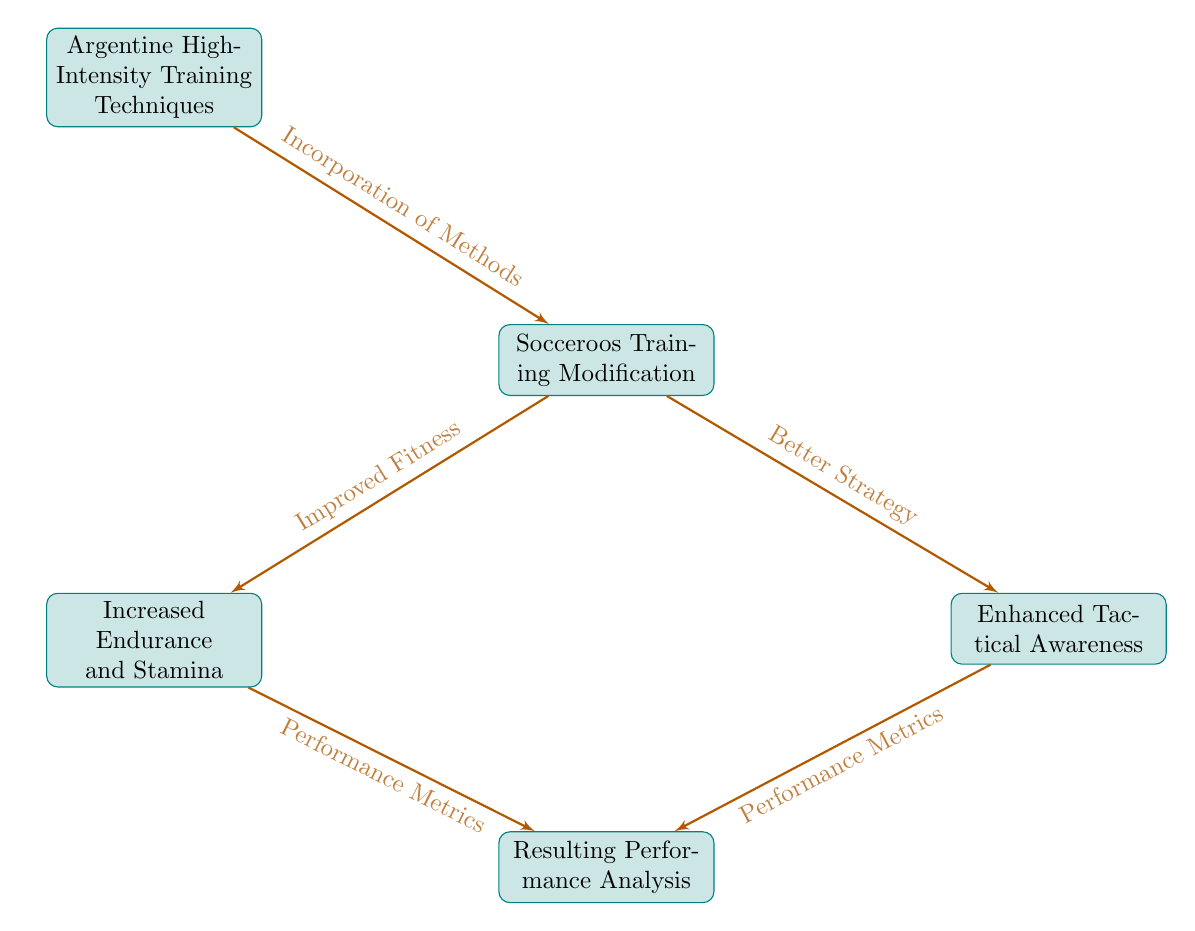What is the title of the first node? The first node is labeled "Argentine High-Intensity Training Techniques," which is the starting point of the flow chart.
Answer: Argentine High-Intensity Training Techniques How many nodes are in the diagram? The diagram consists of five distinct nodes that outline the various influences and modifications related to training.
Answer: 5 What is the relationship between "Socceroos Training Modification" and "Increased Endurance and Stamina"? "Socceroos Training Modification" leads to "Increased Endurance and Stamina" through the connection indicating "Improved Fitness," showing that the modification directly contributes to better fitness.
Answer: Improved Fitness What are two results that come from "Socceroos Training Modification"? From "Socceroos Training Modification," the two outcomes are "Increased Endurance and Stamina" and "Enhanced Tactical Awareness." This indicates that the changes in training impact both fitness and strategy.
Answer: Increased Endurance and Stamina, Enhanced Tactical Awareness What metrics are collected in "Resulting Performance Analysis"? The "Resulting Performance Analysis" node takes into account performance metrics from both "Increased Endurance and Stamina" and "Enhanced Tactical Awareness" to evaluate the overall effectiveness of the training modifications.
Answer: Performance Metrics How does "Argentine High-Intensity Training Techniques" contribute to the Socceroos' training regime? The Argentine techniques are incorporated into the Socceroos' training regime, which influences their conditioning and strategic approach to the game. This integration is essential for adopting new training methods.
Answer: Incorporation of Methods What is the end goal of the flow chart? The flow chart ultimately leads to "Resulting Performance Analysis," which represents the assessment of the influences of Argentine techniques on the Socceroos' performance.
Answer: Resulting Performance Analysis 